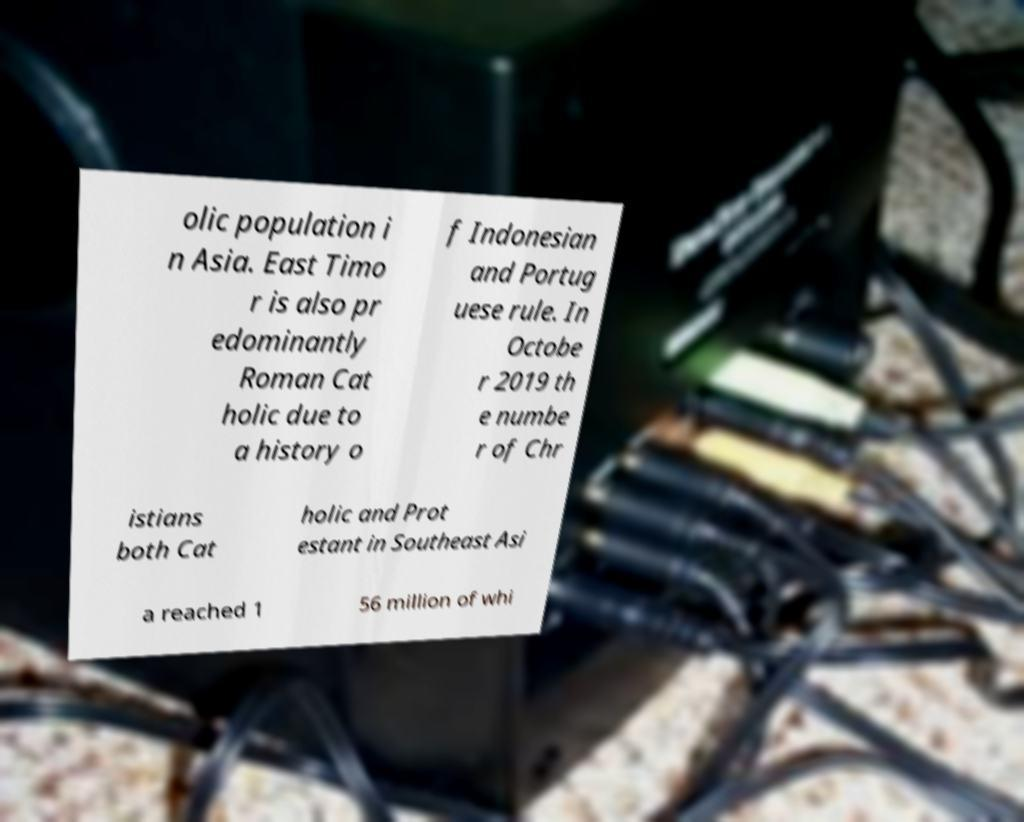I need the written content from this picture converted into text. Can you do that? olic population i n Asia. East Timo r is also pr edominantly Roman Cat holic due to a history o f Indonesian and Portug uese rule. In Octobe r 2019 th e numbe r of Chr istians both Cat holic and Prot estant in Southeast Asi a reached 1 56 million of whi 